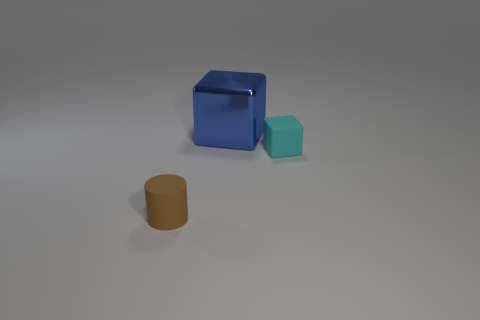Add 3 tiny cyan rubber blocks. How many objects exist? 6 Subtract all cylinders. How many objects are left? 2 Subtract all green cylinders. Subtract all yellow blocks. How many cylinders are left? 1 Subtract all red metal cylinders. Subtract all big metallic cubes. How many objects are left? 2 Add 2 big blue blocks. How many big blue blocks are left? 3 Add 2 large yellow things. How many large yellow things exist? 2 Subtract all blue blocks. How many blocks are left? 1 Subtract 0 green blocks. How many objects are left? 3 Subtract 2 blocks. How many blocks are left? 0 